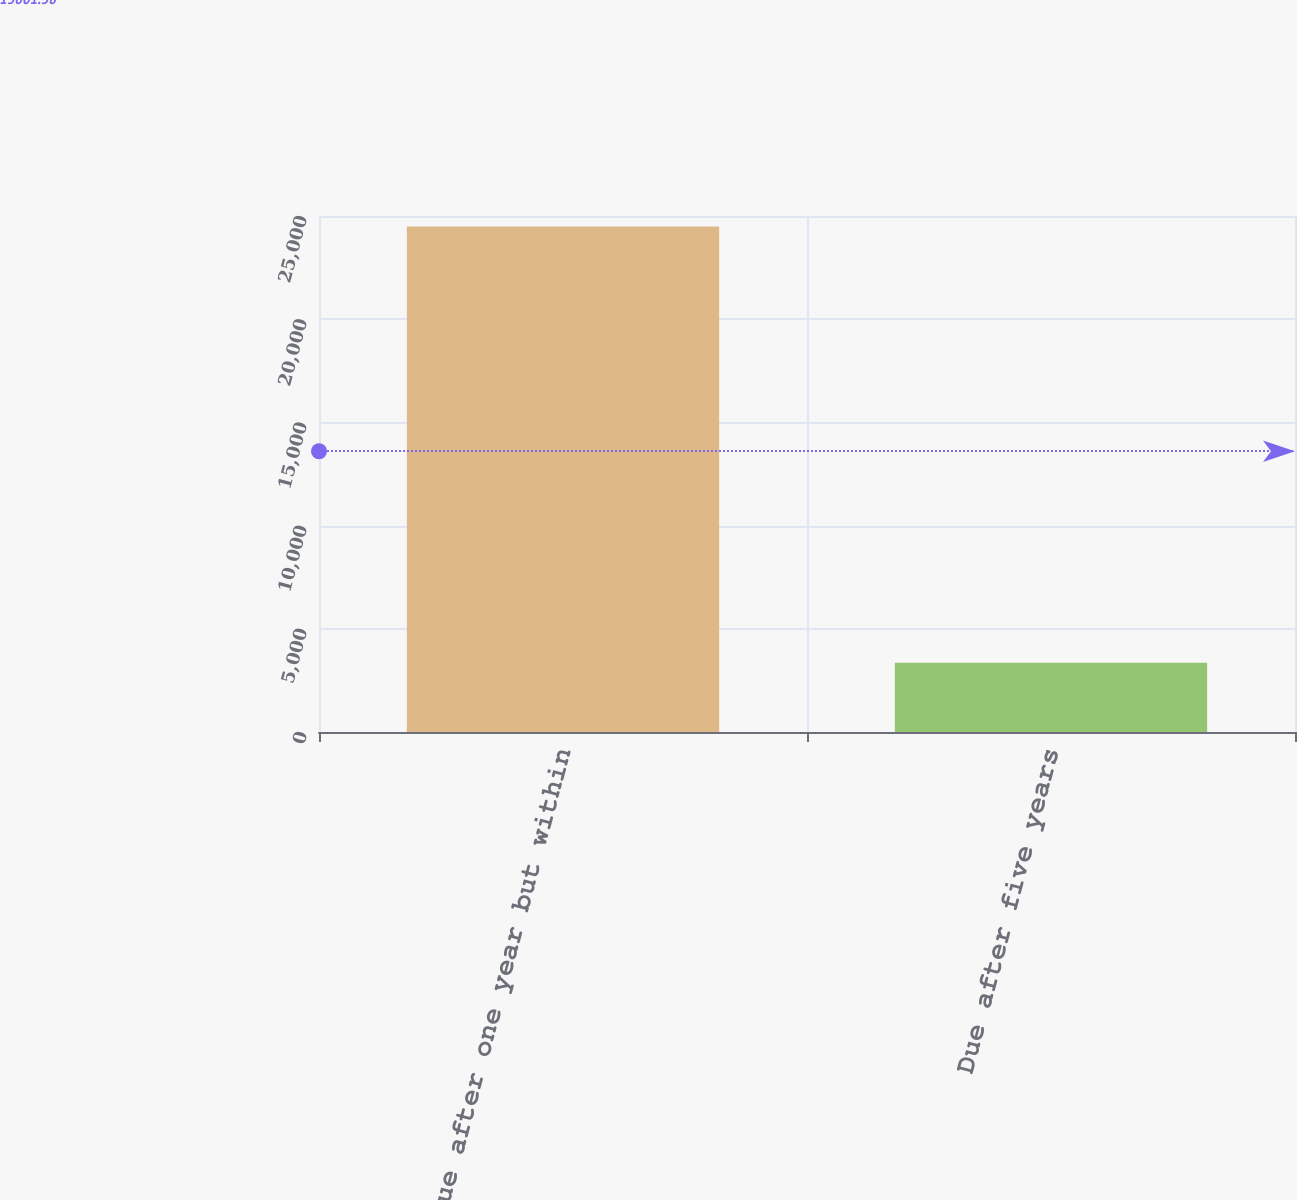Convert chart to OTSL. <chart><loc_0><loc_0><loc_500><loc_500><bar_chart><fcel>Due after one year but within<fcel>Due after five years<nl><fcel>24486<fcel>3354<nl></chart> 